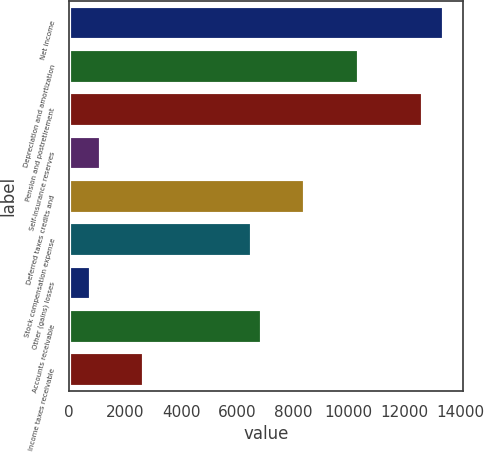Convert chart. <chart><loc_0><loc_0><loc_500><loc_500><bar_chart><fcel>Net income<fcel>Depreciation and amortization<fcel>Pension and postretirement<fcel>Self-insurance reserves<fcel>Deferred taxes credits and<fcel>Stock compensation expense<fcel>Other (gains) losses<fcel>Accounts receivable<fcel>Income taxes receivable<nl><fcel>13417.5<fcel>10351.1<fcel>12650.9<fcel>1151.9<fcel>8434.6<fcel>6518.1<fcel>768.6<fcel>6901.4<fcel>2685.1<nl></chart> 